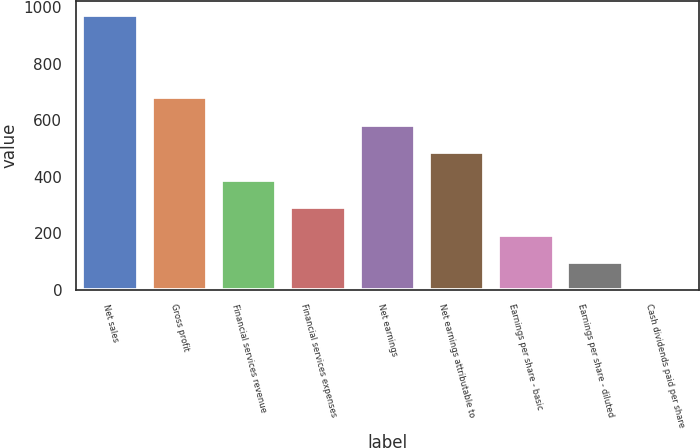<chart> <loc_0><loc_0><loc_500><loc_500><bar_chart><fcel>Net sales<fcel>Gross profit<fcel>Financial services revenue<fcel>Financial services expenses<fcel>Net earnings<fcel>Net earnings attributable to<fcel>Earnings per share - basic<fcel>Earnings per share - diluted<fcel>Cash dividends paid per share<nl><fcel>974.6<fcel>682.48<fcel>390.34<fcel>292.96<fcel>585.1<fcel>487.72<fcel>195.58<fcel>98.2<fcel>0.82<nl></chart> 